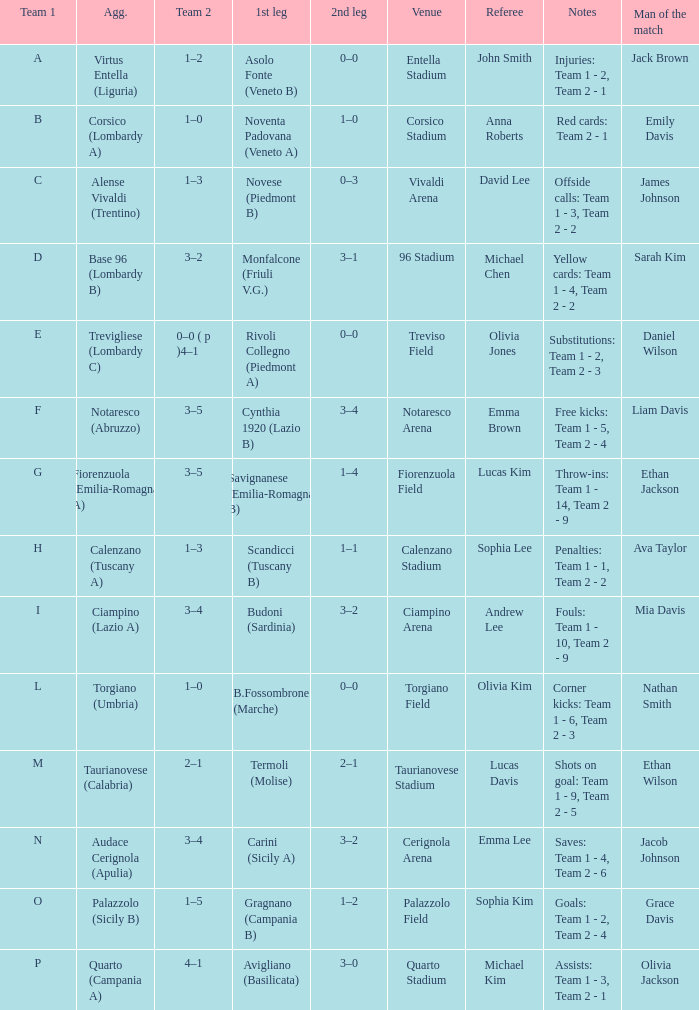What 1st leg has Alense Vivaldi (Trentino) as Agg.? Novese (Piedmont B). 